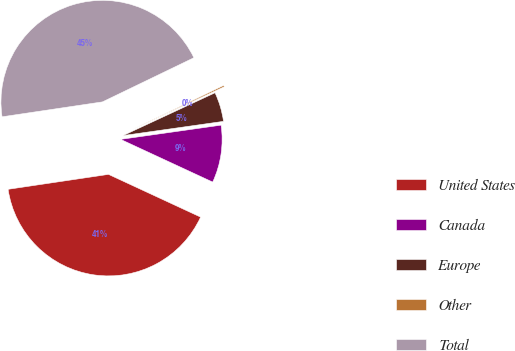<chart> <loc_0><loc_0><loc_500><loc_500><pie_chart><fcel>United States<fcel>Canada<fcel>Europe<fcel>Other<fcel>Total<nl><fcel>40.74%<fcel>9.15%<fcel>4.69%<fcel>0.23%<fcel>45.19%<nl></chart> 